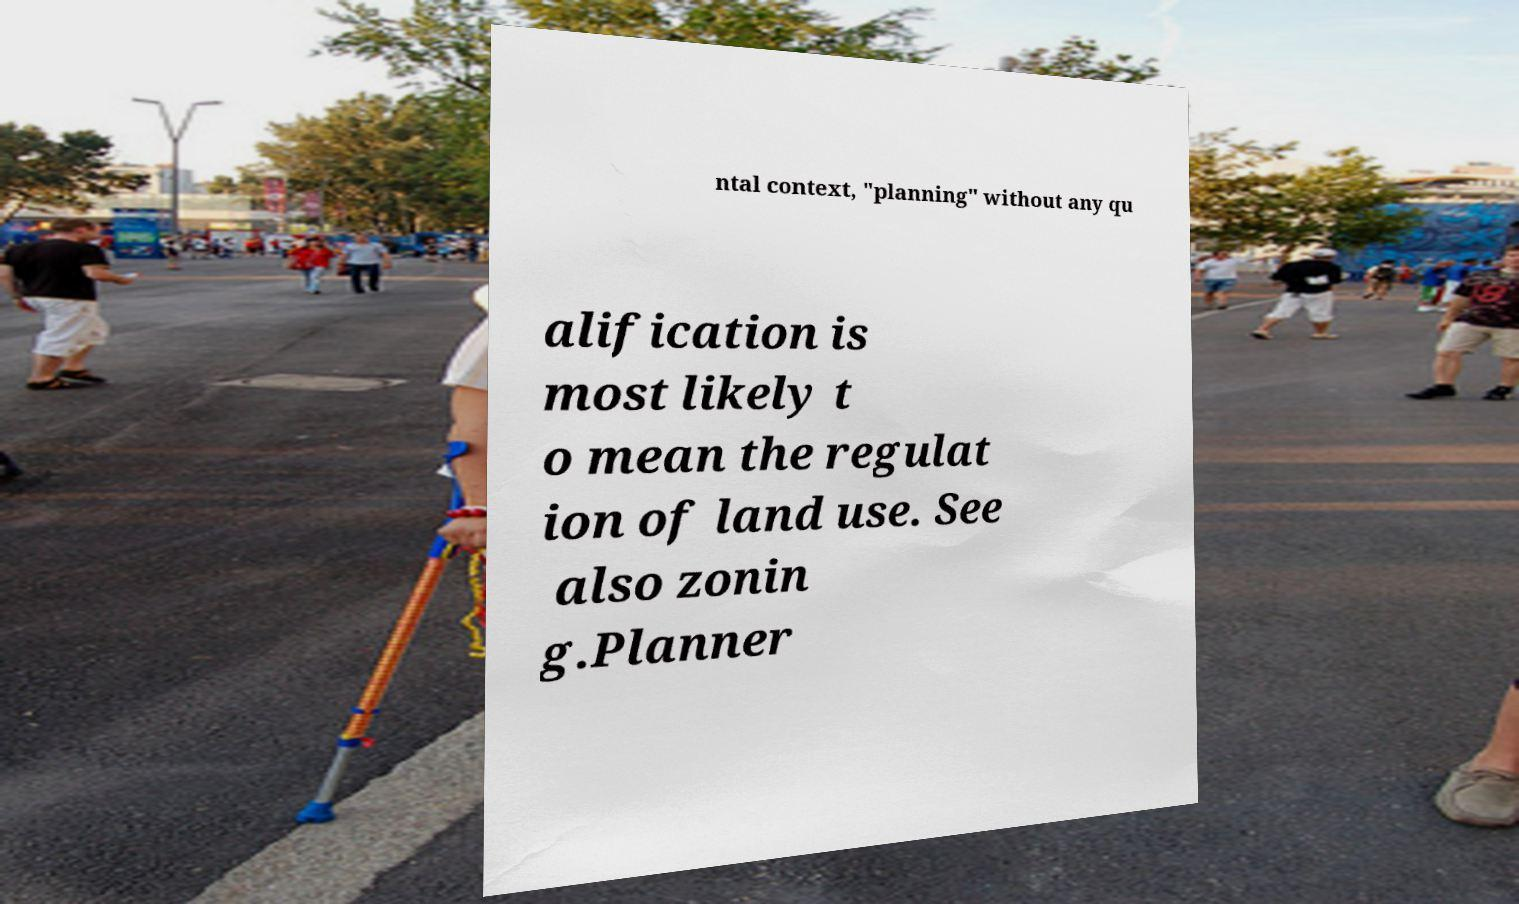Please read and relay the text visible in this image. What does it say? ntal context, "planning" without any qu alification is most likely t o mean the regulat ion of land use. See also zonin g.Planner 